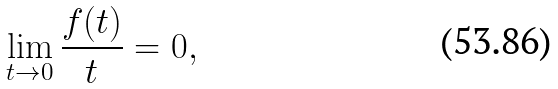Convert formula to latex. <formula><loc_0><loc_0><loc_500><loc_500>\lim _ { t \to 0 } \frac { f ( t ) } { t } = 0 ,</formula> 